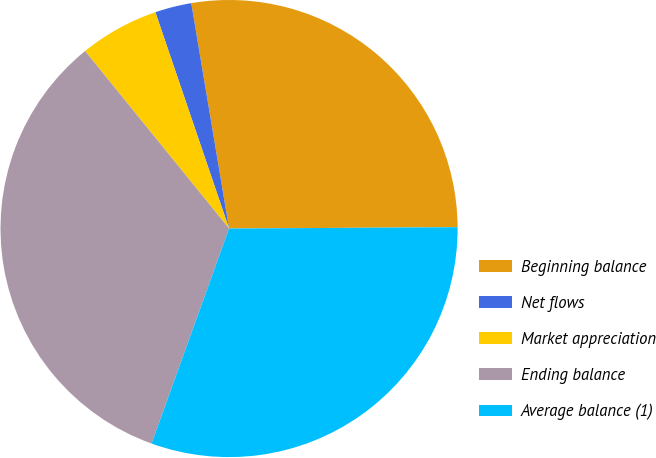<chart> <loc_0><loc_0><loc_500><loc_500><pie_chart><fcel>Beginning balance<fcel>Net flows<fcel>Market appreciation<fcel>Ending balance<fcel>Average balance (1)<nl><fcel>27.55%<fcel>2.58%<fcel>5.62%<fcel>33.65%<fcel>30.6%<nl></chart> 